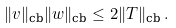<formula> <loc_0><loc_0><loc_500><loc_500>\| v \| _ { \text {cb} } \| w \| _ { \text {cb} } \leq 2 \| T \| _ { \text {cb} } \, .</formula> 